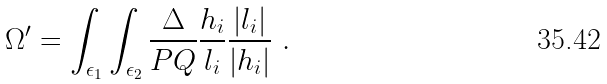Convert formula to latex. <formula><loc_0><loc_0><loc_500><loc_500>\Omega ^ { \prime } = \int _ { \epsilon _ { 1 } } \int _ { \epsilon _ { 2 } } \frac { \Delta } { P Q } \frac { h _ { i } } { l _ { i } } \frac { | l _ { i } | } { | h _ { i } | } \ .</formula> 